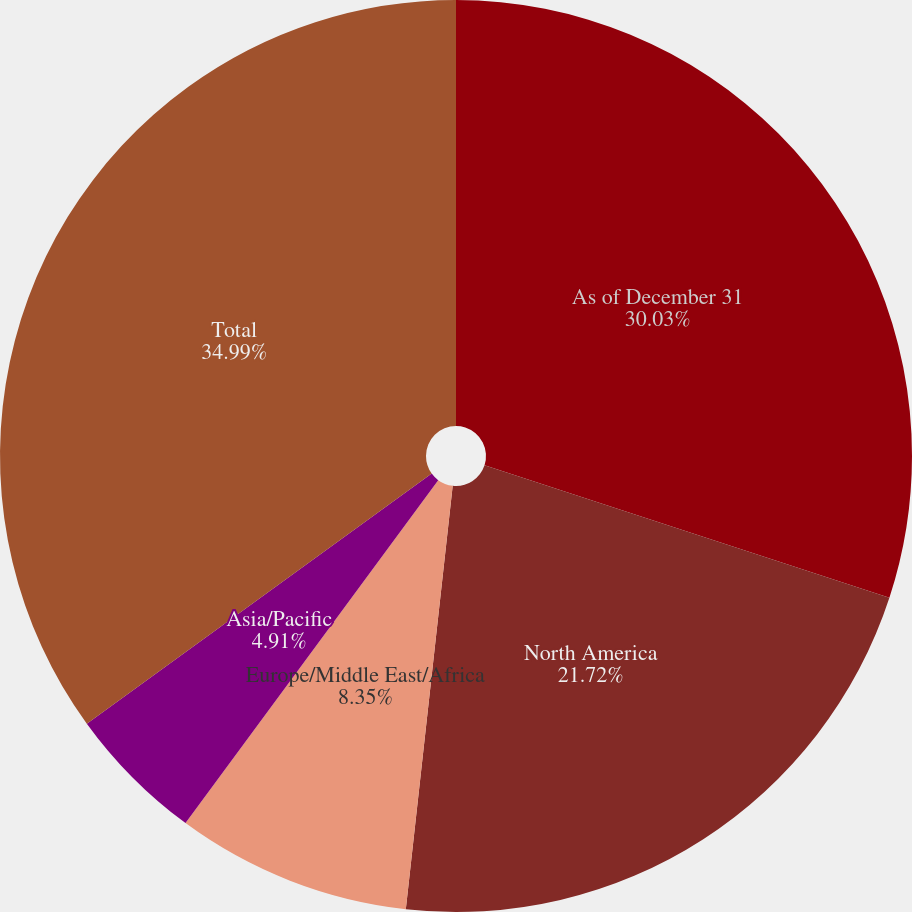Convert chart. <chart><loc_0><loc_0><loc_500><loc_500><pie_chart><fcel>As of December 31<fcel>North America<fcel>Europe/Middle East/Africa<fcel>Asia/Pacific<fcel>Total<nl><fcel>30.03%<fcel>21.72%<fcel>8.35%<fcel>4.91%<fcel>34.98%<nl></chart> 